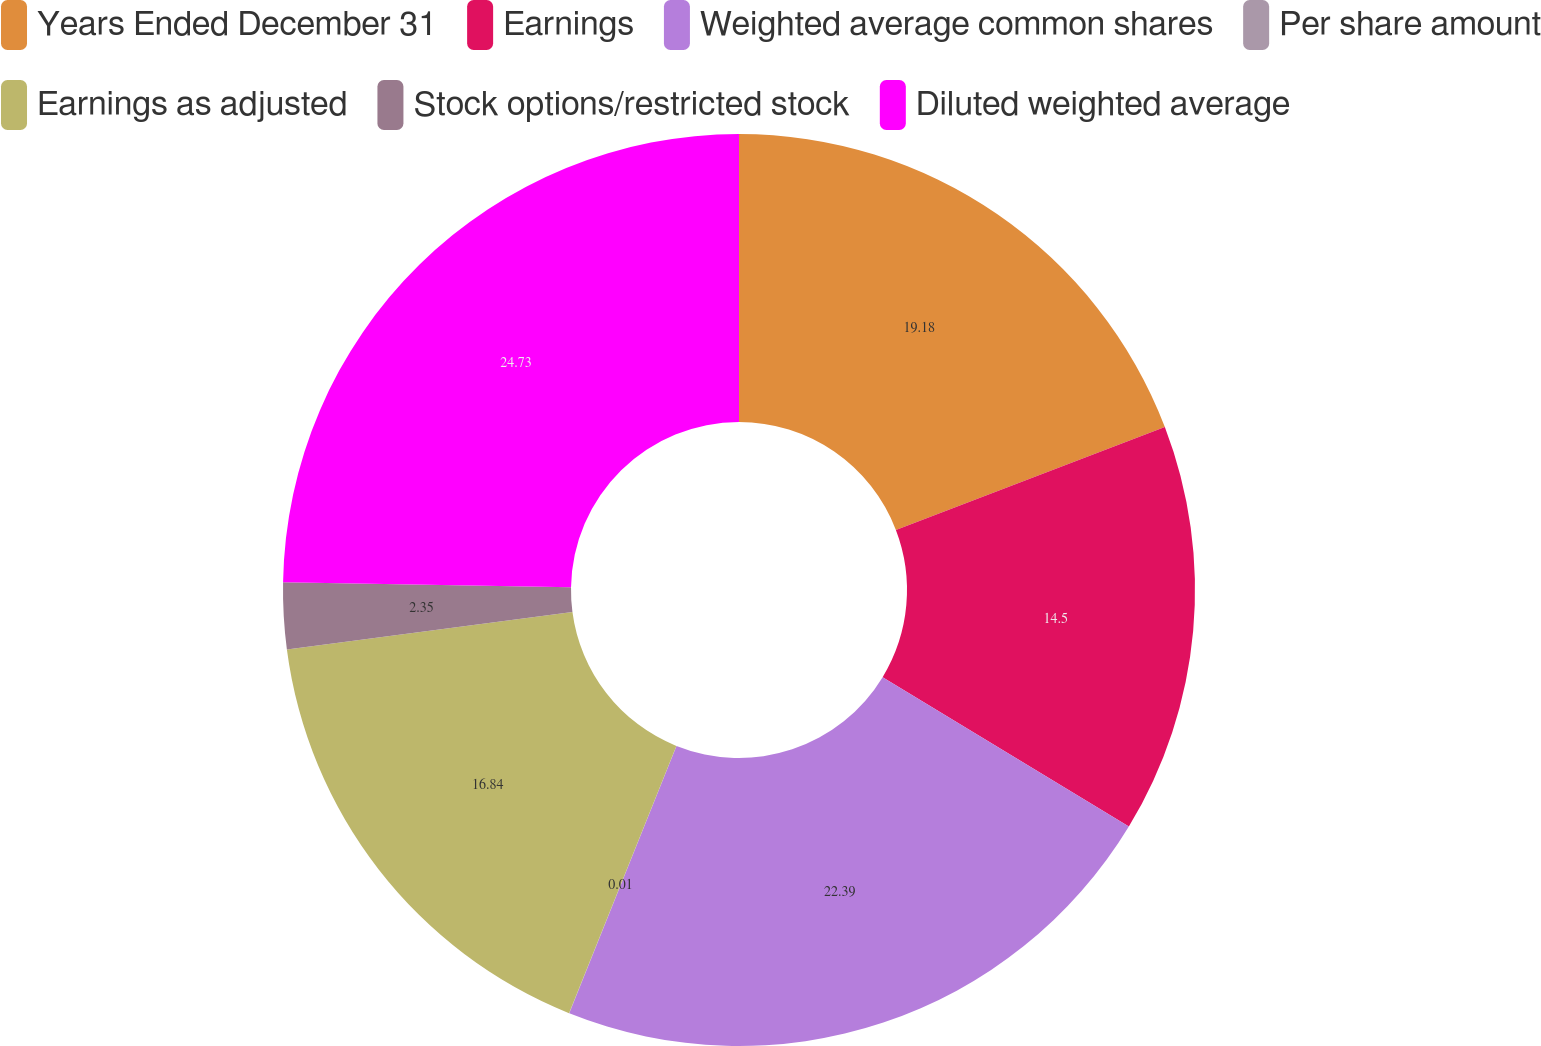<chart> <loc_0><loc_0><loc_500><loc_500><pie_chart><fcel>Years Ended December 31<fcel>Earnings<fcel>Weighted average common shares<fcel>Per share amount<fcel>Earnings as adjusted<fcel>Stock options/restricted stock<fcel>Diluted weighted average<nl><fcel>19.18%<fcel>14.5%<fcel>22.39%<fcel>0.01%<fcel>16.84%<fcel>2.35%<fcel>24.73%<nl></chart> 